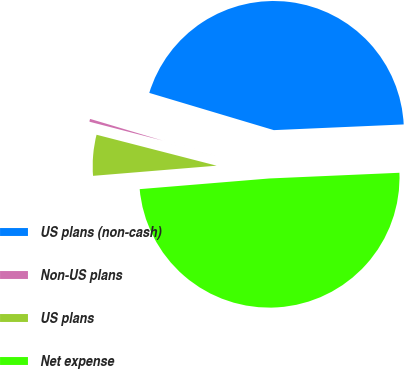<chart> <loc_0><loc_0><loc_500><loc_500><pie_chart><fcel>US plans (non-cash)<fcel>Non-US plans<fcel>US plans<fcel>Net expense<nl><fcel>44.68%<fcel>0.61%<fcel>5.32%<fcel>49.39%<nl></chart> 